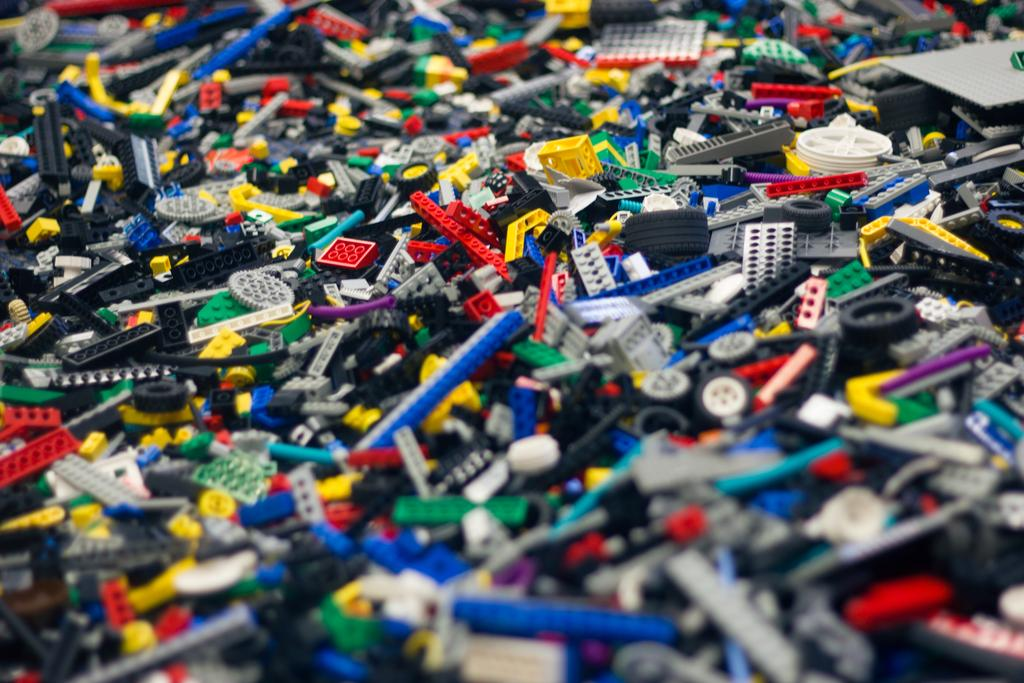What type of objects are present in the image? There is a collection of toys in the image. Can you describe the appearance of the toys? The toys are in different colors and different sizes. What can be seen in the background of the image? The backdrop of the image is blurred. Where is the scarecrow standing in the image? There is no scarecrow present in the image. What type of soda is the dad drinking in the image? There is no dad or soda present in the image. 